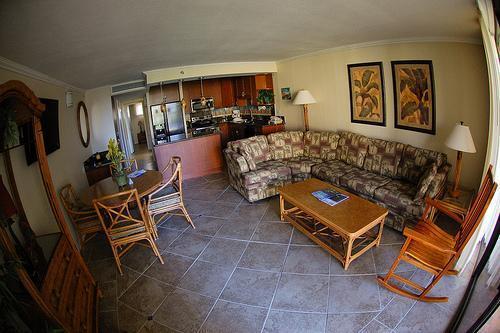How many lamps are in this photo?
Give a very brief answer. 2. 